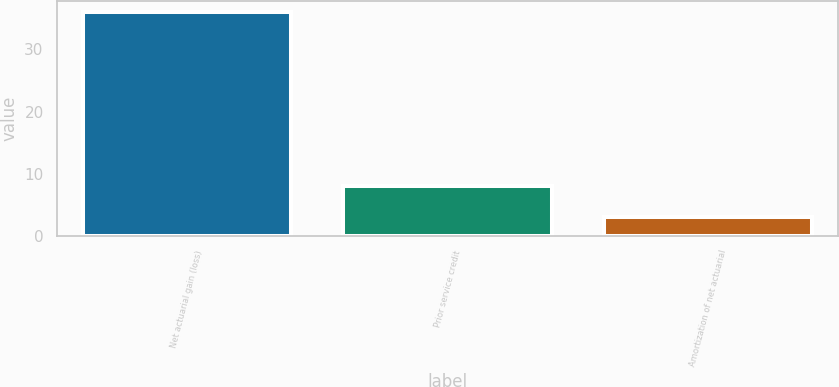Convert chart. <chart><loc_0><loc_0><loc_500><loc_500><bar_chart><fcel>Net actuarial gain (loss)<fcel>Prior service credit<fcel>Amortization of net actuarial<nl><fcel>36<fcel>8<fcel>3<nl></chart> 